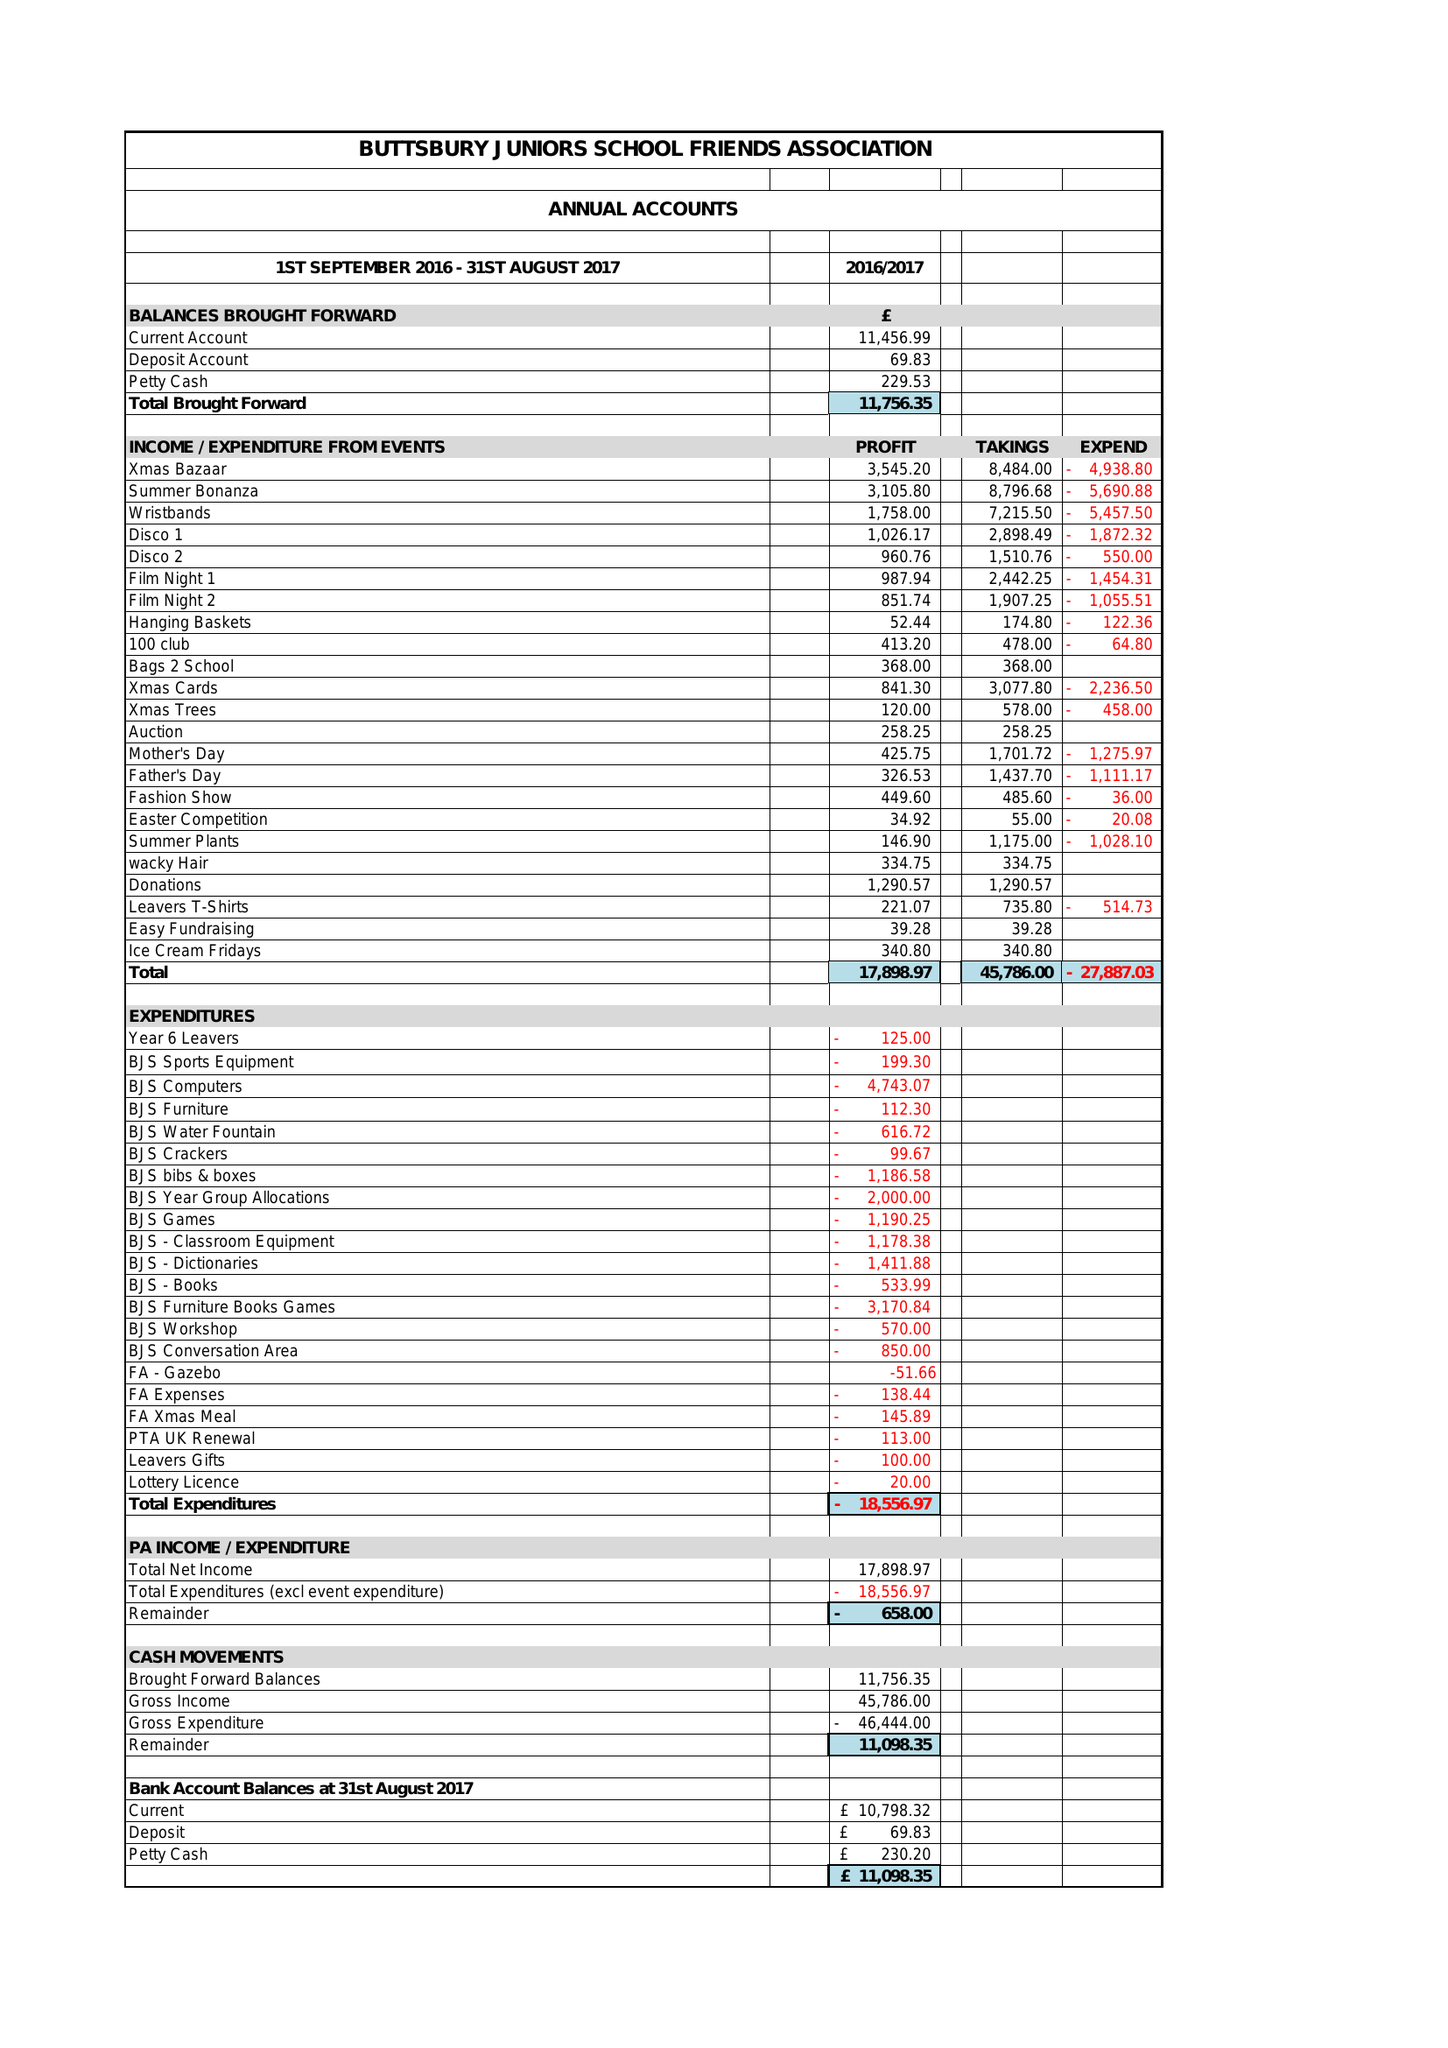What is the value for the income_annually_in_british_pounds?
Answer the question using a single word or phrase. 45786.00 